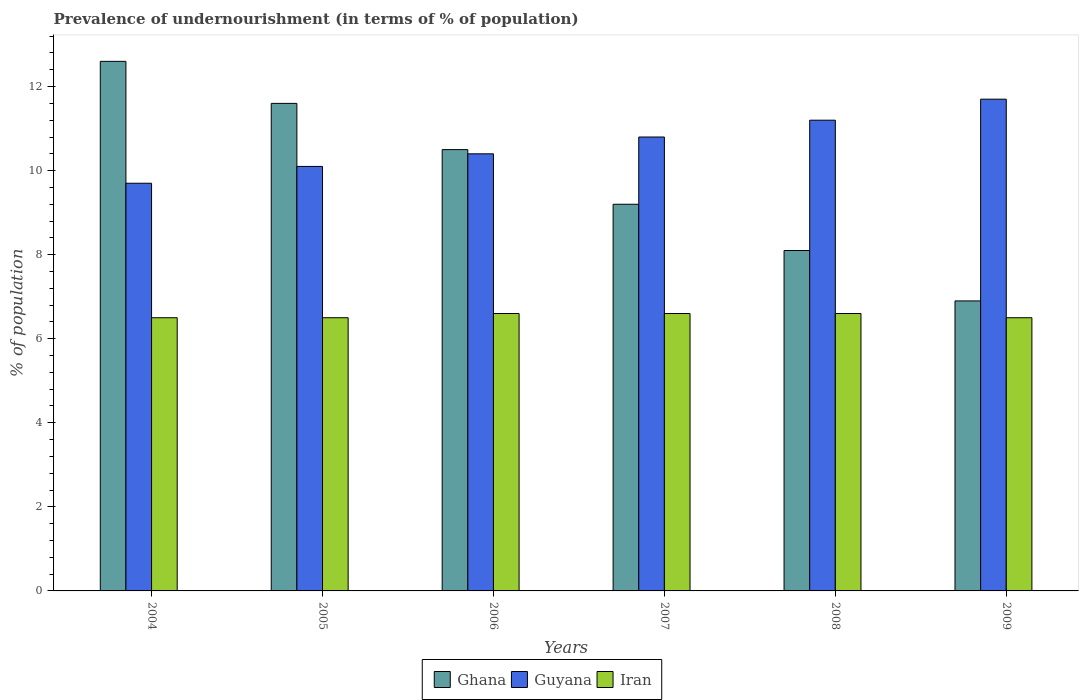How many different coloured bars are there?
Ensure brevity in your answer.  3. How many groups of bars are there?
Offer a very short reply. 6. Are the number of bars on each tick of the X-axis equal?
Offer a terse response. Yes. How many bars are there on the 1st tick from the right?
Keep it short and to the point. 3. What is the label of the 4th group of bars from the left?
Provide a short and direct response. 2007. What is the percentage of undernourished population in Ghana in 2005?
Your response must be concise. 11.6. Across all years, what is the minimum percentage of undernourished population in Ghana?
Keep it short and to the point. 6.9. In which year was the percentage of undernourished population in Guyana minimum?
Provide a succinct answer. 2004. What is the total percentage of undernourished population in Iran in the graph?
Your response must be concise. 39.3. What is the difference between the percentage of undernourished population in Ghana in 2004 and that in 2008?
Provide a succinct answer. 4.5. What is the difference between the percentage of undernourished population in Guyana in 2009 and the percentage of undernourished population in Iran in 2004?
Your answer should be compact. 5.2. What is the average percentage of undernourished population in Ghana per year?
Give a very brief answer. 9.82. In the year 2006, what is the difference between the percentage of undernourished population in Ghana and percentage of undernourished population in Iran?
Offer a terse response. 3.9. In how many years, is the percentage of undernourished population in Iran greater than 4.8 %?
Your answer should be very brief. 6. What is the ratio of the percentage of undernourished population in Guyana in 2006 to that in 2008?
Provide a succinct answer. 0.93. Is the difference between the percentage of undernourished population in Ghana in 2007 and 2008 greater than the difference between the percentage of undernourished population in Iran in 2007 and 2008?
Your answer should be compact. Yes. What is the difference between the highest and the lowest percentage of undernourished population in Ghana?
Ensure brevity in your answer.  5.7. In how many years, is the percentage of undernourished population in Guyana greater than the average percentage of undernourished population in Guyana taken over all years?
Your response must be concise. 3. Is the sum of the percentage of undernourished population in Guyana in 2006 and 2009 greater than the maximum percentage of undernourished population in Ghana across all years?
Keep it short and to the point. Yes. What does the 3rd bar from the left in 2005 represents?
Your response must be concise. Iran. What does the 2nd bar from the right in 2004 represents?
Your answer should be compact. Guyana. Is it the case that in every year, the sum of the percentage of undernourished population in Ghana and percentage of undernourished population in Iran is greater than the percentage of undernourished population in Guyana?
Keep it short and to the point. Yes. How many bars are there?
Make the answer very short. 18. How many years are there in the graph?
Your response must be concise. 6. Are the values on the major ticks of Y-axis written in scientific E-notation?
Keep it short and to the point. No. Does the graph contain any zero values?
Provide a short and direct response. No. Does the graph contain grids?
Your response must be concise. No. What is the title of the graph?
Make the answer very short. Prevalence of undernourishment (in terms of % of population). What is the label or title of the Y-axis?
Provide a short and direct response. % of population. What is the % of population of Ghana in 2004?
Your response must be concise. 12.6. What is the % of population in Guyana in 2004?
Ensure brevity in your answer.  9.7. What is the % of population in Iran in 2005?
Make the answer very short. 6.5. What is the % of population of Ghana in 2006?
Keep it short and to the point. 10.5. What is the % of population in Guyana in 2006?
Ensure brevity in your answer.  10.4. What is the % of population of Iran in 2006?
Your answer should be very brief. 6.6. What is the % of population in Ghana in 2007?
Make the answer very short. 9.2. What is the % of population in Iran in 2007?
Your response must be concise. 6.6. What is the % of population in Ghana in 2008?
Provide a short and direct response. 8.1. What is the % of population of Guyana in 2008?
Offer a very short reply. 11.2. What is the % of population of Ghana in 2009?
Keep it short and to the point. 6.9. What is the % of population in Guyana in 2009?
Your answer should be compact. 11.7. What is the % of population in Iran in 2009?
Provide a succinct answer. 6.5. Across all years, what is the maximum % of population in Ghana?
Give a very brief answer. 12.6. What is the total % of population of Ghana in the graph?
Your answer should be compact. 58.9. What is the total % of population in Guyana in the graph?
Ensure brevity in your answer.  63.9. What is the total % of population of Iran in the graph?
Your answer should be compact. 39.3. What is the difference between the % of population of Guyana in 2004 and that in 2005?
Offer a very short reply. -0.4. What is the difference between the % of population in Iran in 2004 and that in 2005?
Your answer should be compact. 0. What is the difference between the % of population in Guyana in 2004 and that in 2006?
Provide a succinct answer. -0.7. What is the difference between the % of population in Ghana in 2004 and that in 2007?
Make the answer very short. 3.4. What is the difference between the % of population of Guyana in 2004 and that in 2007?
Your response must be concise. -1.1. What is the difference between the % of population in Iran in 2004 and that in 2007?
Keep it short and to the point. -0.1. What is the difference between the % of population in Ghana in 2004 and that in 2008?
Provide a short and direct response. 4.5. What is the difference between the % of population of Ghana in 2004 and that in 2009?
Offer a very short reply. 5.7. What is the difference between the % of population in Iran in 2004 and that in 2009?
Your answer should be very brief. 0. What is the difference between the % of population in Guyana in 2005 and that in 2006?
Ensure brevity in your answer.  -0.3. What is the difference between the % of population in Guyana in 2005 and that in 2007?
Offer a terse response. -0.7. What is the difference between the % of population in Iran in 2005 and that in 2007?
Ensure brevity in your answer.  -0.1. What is the difference between the % of population in Iran in 2005 and that in 2008?
Your answer should be very brief. -0.1. What is the difference between the % of population in Iran in 2005 and that in 2009?
Offer a terse response. 0. What is the difference between the % of population of Ghana in 2006 and that in 2007?
Your answer should be compact. 1.3. What is the difference between the % of population of Guyana in 2006 and that in 2007?
Give a very brief answer. -0.4. What is the difference between the % of population in Ghana in 2006 and that in 2008?
Give a very brief answer. 2.4. What is the difference between the % of population in Guyana in 2006 and that in 2008?
Keep it short and to the point. -0.8. What is the difference between the % of population of Ghana in 2006 and that in 2009?
Make the answer very short. 3.6. What is the difference between the % of population in Ghana in 2007 and that in 2008?
Provide a short and direct response. 1.1. What is the difference between the % of population in Ghana in 2007 and that in 2009?
Make the answer very short. 2.3. What is the difference between the % of population in Iran in 2007 and that in 2009?
Give a very brief answer. 0.1. What is the difference between the % of population of Iran in 2008 and that in 2009?
Ensure brevity in your answer.  0.1. What is the difference between the % of population in Ghana in 2004 and the % of population in Guyana in 2005?
Provide a succinct answer. 2.5. What is the difference between the % of population in Ghana in 2004 and the % of population in Iran in 2005?
Ensure brevity in your answer.  6.1. What is the difference between the % of population in Ghana in 2004 and the % of population in Guyana in 2007?
Make the answer very short. 1.8. What is the difference between the % of population in Ghana in 2004 and the % of population in Iran in 2007?
Offer a very short reply. 6. What is the difference between the % of population of Guyana in 2004 and the % of population of Iran in 2007?
Your response must be concise. 3.1. What is the difference between the % of population in Ghana in 2004 and the % of population in Iran in 2008?
Give a very brief answer. 6. What is the difference between the % of population in Ghana in 2004 and the % of population in Iran in 2009?
Offer a terse response. 6.1. What is the difference between the % of population of Ghana in 2005 and the % of population of Iran in 2006?
Provide a succinct answer. 5. What is the difference between the % of population in Guyana in 2005 and the % of population in Iran in 2006?
Your answer should be very brief. 3.5. What is the difference between the % of population in Ghana in 2005 and the % of population in Guyana in 2007?
Offer a very short reply. 0.8. What is the difference between the % of population in Guyana in 2005 and the % of population in Iran in 2007?
Offer a very short reply. 3.5. What is the difference between the % of population in Ghana in 2005 and the % of population in Guyana in 2008?
Give a very brief answer. 0.4. What is the difference between the % of population of Guyana in 2005 and the % of population of Iran in 2008?
Provide a succinct answer. 3.5. What is the difference between the % of population of Ghana in 2005 and the % of population of Guyana in 2009?
Your answer should be compact. -0.1. What is the difference between the % of population of Ghana in 2005 and the % of population of Iran in 2009?
Your answer should be very brief. 5.1. What is the difference between the % of population of Ghana in 2006 and the % of population of Guyana in 2007?
Ensure brevity in your answer.  -0.3. What is the difference between the % of population of Guyana in 2006 and the % of population of Iran in 2007?
Offer a very short reply. 3.8. What is the difference between the % of population in Ghana in 2006 and the % of population in Guyana in 2008?
Your answer should be compact. -0.7. What is the difference between the % of population in Ghana in 2006 and the % of population in Iran in 2008?
Your answer should be very brief. 3.9. What is the difference between the % of population of Guyana in 2006 and the % of population of Iran in 2008?
Your answer should be very brief. 3.8. What is the difference between the % of population in Ghana in 2006 and the % of population in Guyana in 2009?
Offer a very short reply. -1.2. What is the difference between the % of population in Ghana in 2006 and the % of population in Iran in 2009?
Offer a very short reply. 4. What is the difference between the % of population in Guyana in 2006 and the % of population in Iran in 2009?
Provide a short and direct response. 3.9. What is the difference between the % of population in Ghana in 2007 and the % of population in Guyana in 2008?
Give a very brief answer. -2. What is the difference between the % of population of Ghana in 2007 and the % of population of Guyana in 2009?
Make the answer very short. -2.5. What is the difference between the % of population of Ghana in 2007 and the % of population of Iran in 2009?
Provide a short and direct response. 2.7. What is the difference between the % of population of Ghana in 2008 and the % of population of Iran in 2009?
Offer a very short reply. 1.6. What is the average % of population in Ghana per year?
Your response must be concise. 9.82. What is the average % of population of Guyana per year?
Provide a succinct answer. 10.65. What is the average % of population of Iran per year?
Make the answer very short. 6.55. In the year 2005, what is the difference between the % of population in Ghana and % of population in Iran?
Your answer should be compact. 5.1. In the year 2005, what is the difference between the % of population in Guyana and % of population in Iran?
Your response must be concise. 3.6. In the year 2006, what is the difference between the % of population in Ghana and % of population in Iran?
Offer a terse response. 3.9. In the year 2006, what is the difference between the % of population in Guyana and % of population in Iran?
Make the answer very short. 3.8. In the year 2007, what is the difference between the % of population of Ghana and % of population of Guyana?
Your answer should be very brief. -1.6. In the year 2007, what is the difference between the % of population of Ghana and % of population of Iran?
Provide a short and direct response. 2.6. In the year 2008, what is the difference between the % of population of Ghana and % of population of Iran?
Offer a very short reply. 1.5. What is the ratio of the % of population of Ghana in 2004 to that in 2005?
Offer a very short reply. 1.09. What is the ratio of the % of population in Guyana in 2004 to that in 2005?
Your answer should be very brief. 0.96. What is the ratio of the % of population in Ghana in 2004 to that in 2006?
Keep it short and to the point. 1.2. What is the ratio of the % of population in Guyana in 2004 to that in 2006?
Make the answer very short. 0.93. What is the ratio of the % of population in Iran in 2004 to that in 2006?
Offer a terse response. 0.98. What is the ratio of the % of population of Ghana in 2004 to that in 2007?
Provide a short and direct response. 1.37. What is the ratio of the % of population of Guyana in 2004 to that in 2007?
Provide a succinct answer. 0.9. What is the ratio of the % of population of Ghana in 2004 to that in 2008?
Ensure brevity in your answer.  1.56. What is the ratio of the % of population in Guyana in 2004 to that in 2008?
Your answer should be compact. 0.87. What is the ratio of the % of population of Iran in 2004 to that in 2008?
Your response must be concise. 0.98. What is the ratio of the % of population in Ghana in 2004 to that in 2009?
Provide a short and direct response. 1.83. What is the ratio of the % of population of Guyana in 2004 to that in 2009?
Give a very brief answer. 0.83. What is the ratio of the % of population of Ghana in 2005 to that in 2006?
Offer a very short reply. 1.1. What is the ratio of the % of population of Guyana in 2005 to that in 2006?
Provide a short and direct response. 0.97. What is the ratio of the % of population in Iran in 2005 to that in 2006?
Provide a short and direct response. 0.98. What is the ratio of the % of population of Ghana in 2005 to that in 2007?
Offer a very short reply. 1.26. What is the ratio of the % of population of Guyana in 2005 to that in 2007?
Offer a very short reply. 0.94. What is the ratio of the % of population in Ghana in 2005 to that in 2008?
Keep it short and to the point. 1.43. What is the ratio of the % of population in Guyana in 2005 to that in 2008?
Offer a terse response. 0.9. What is the ratio of the % of population of Ghana in 2005 to that in 2009?
Ensure brevity in your answer.  1.68. What is the ratio of the % of population of Guyana in 2005 to that in 2009?
Your answer should be compact. 0.86. What is the ratio of the % of population of Iran in 2005 to that in 2009?
Keep it short and to the point. 1. What is the ratio of the % of population of Ghana in 2006 to that in 2007?
Ensure brevity in your answer.  1.14. What is the ratio of the % of population of Ghana in 2006 to that in 2008?
Offer a very short reply. 1.3. What is the ratio of the % of population in Ghana in 2006 to that in 2009?
Keep it short and to the point. 1.52. What is the ratio of the % of population in Guyana in 2006 to that in 2009?
Ensure brevity in your answer.  0.89. What is the ratio of the % of population of Iran in 2006 to that in 2009?
Offer a very short reply. 1.02. What is the ratio of the % of population of Ghana in 2007 to that in 2008?
Provide a short and direct response. 1.14. What is the ratio of the % of population of Ghana in 2007 to that in 2009?
Offer a terse response. 1.33. What is the ratio of the % of population in Guyana in 2007 to that in 2009?
Make the answer very short. 0.92. What is the ratio of the % of population of Iran in 2007 to that in 2009?
Provide a succinct answer. 1.02. What is the ratio of the % of population of Ghana in 2008 to that in 2009?
Your answer should be very brief. 1.17. What is the ratio of the % of population of Guyana in 2008 to that in 2009?
Make the answer very short. 0.96. What is the ratio of the % of population in Iran in 2008 to that in 2009?
Keep it short and to the point. 1.02. What is the difference between the highest and the lowest % of population of Guyana?
Ensure brevity in your answer.  2. What is the difference between the highest and the lowest % of population in Iran?
Provide a short and direct response. 0.1. 